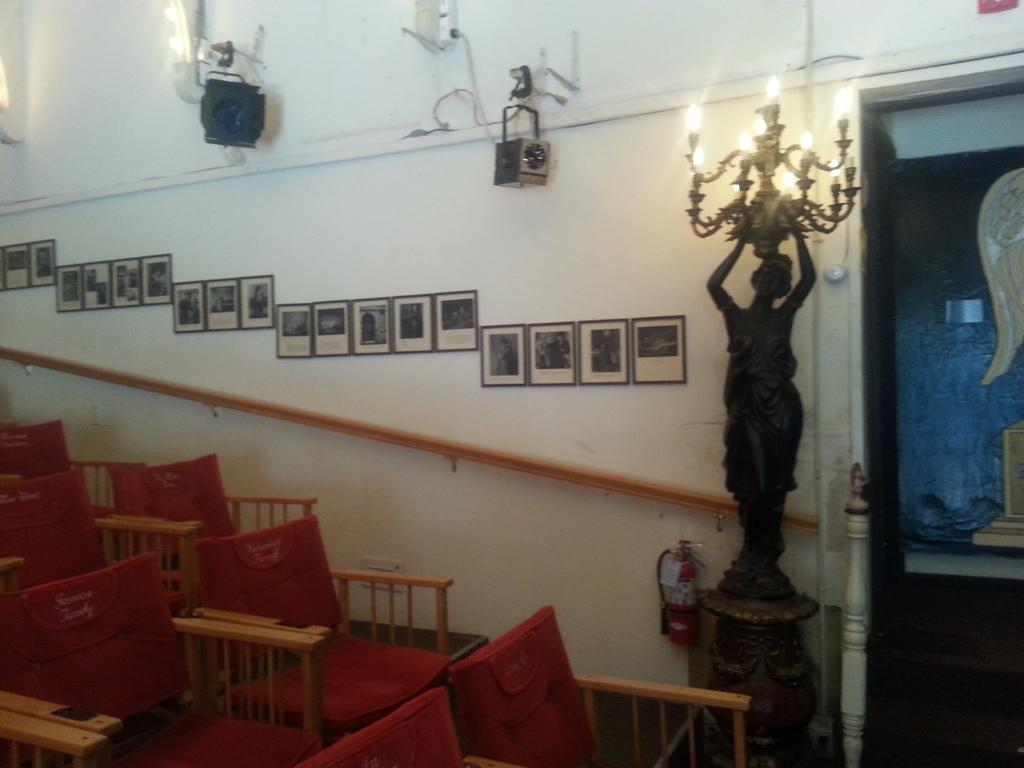What type of furniture is present in the image? There are chairs in the image. What can be seen in the background of the image? There is a statue, lights, and frames attached to the wall in the background of the image. What color is the wall in the image? The wall is in white color. How many people are sleeping on the floor in the image? There is no one sleeping on the floor in the image. What type of cover is used to protect the statue in the image? There is no cover present in the image; the statue is visible without any protection. 